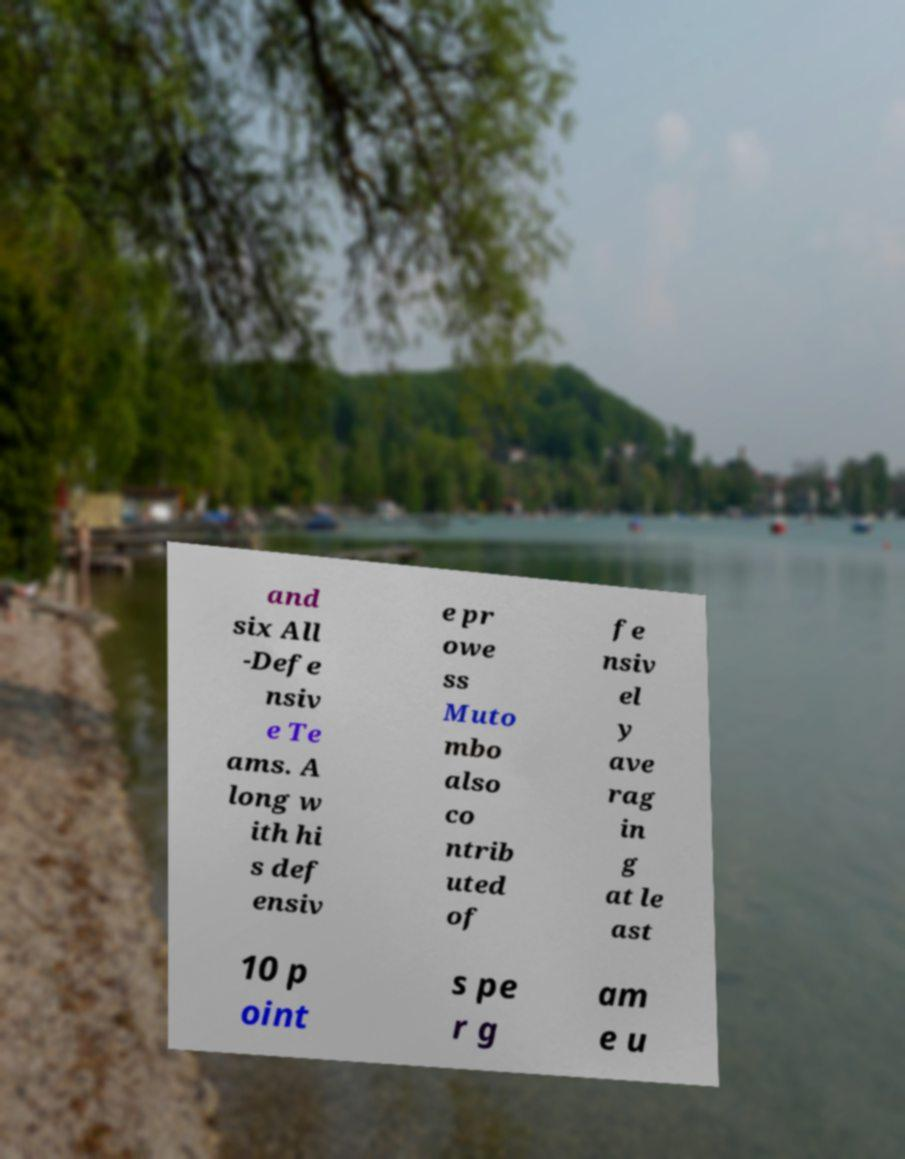I need the written content from this picture converted into text. Can you do that? and six All -Defe nsiv e Te ams. A long w ith hi s def ensiv e pr owe ss Muto mbo also co ntrib uted of fe nsiv el y ave rag in g at le ast 10 p oint s pe r g am e u 